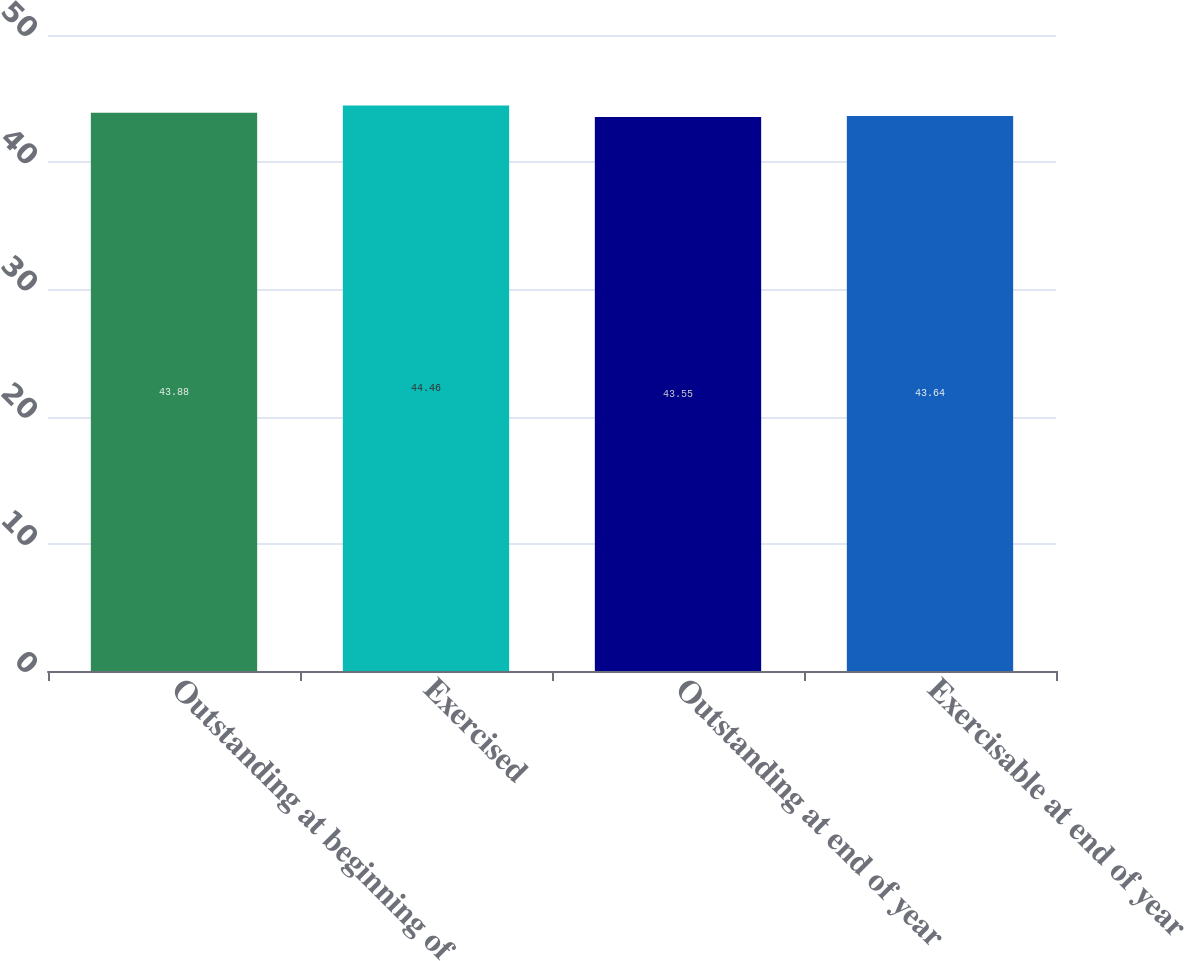Convert chart to OTSL. <chart><loc_0><loc_0><loc_500><loc_500><bar_chart><fcel>Outstanding at beginning of<fcel>Exercised<fcel>Outstanding at end of year<fcel>Exercisable at end of year<nl><fcel>43.88<fcel>44.46<fcel>43.55<fcel>43.64<nl></chart> 